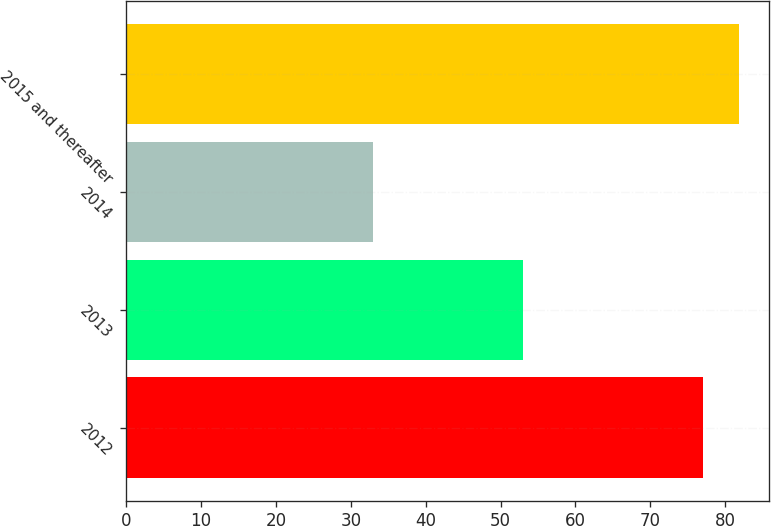<chart> <loc_0><loc_0><loc_500><loc_500><bar_chart><fcel>2012<fcel>2013<fcel>2014<fcel>2015 and thereafter<nl><fcel>77<fcel>53<fcel>33<fcel>81.8<nl></chart> 